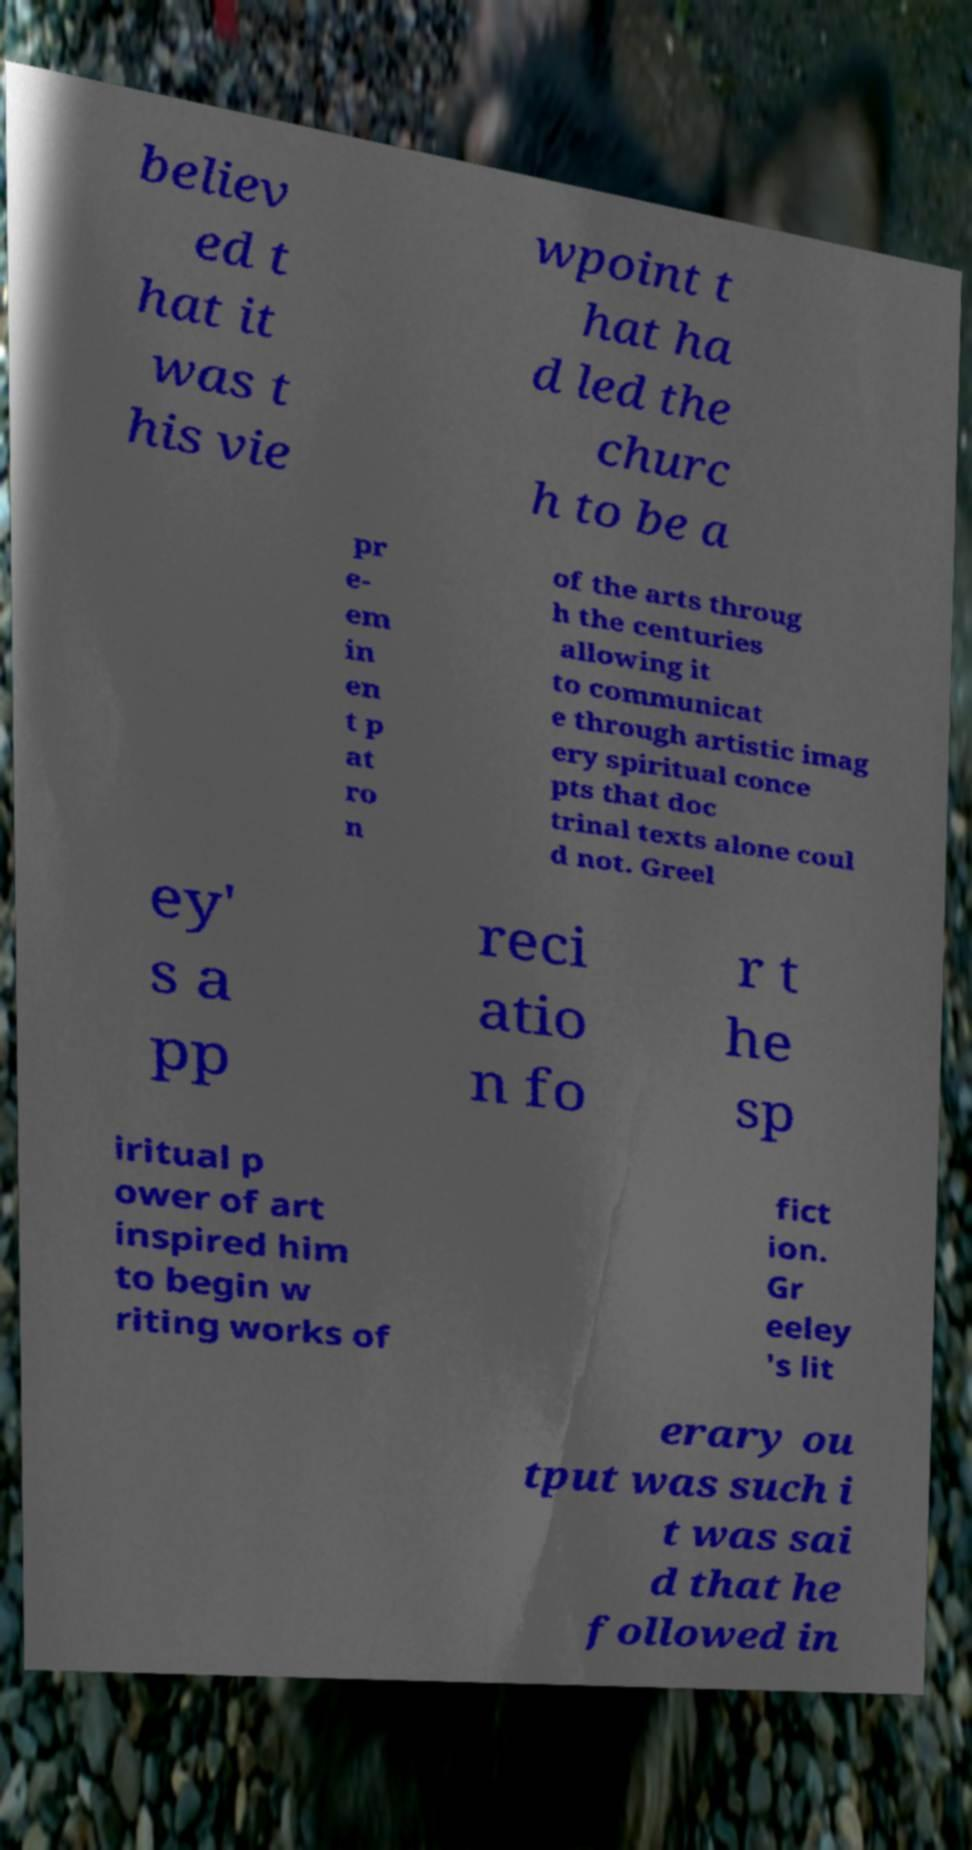Can you read and provide the text displayed in the image?This photo seems to have some interesting text. Can you extract and type it out for me? believ ed t hat it was t his vie wpoint t hat ha d led the churc h to be a pr e- em in en t p at ro n of the arts throug h the centuries allowing it to communicat e through artistic imag ery spiritual conce pts that doc trinal texts alone coul d not. Greel ey' s a pp reci atio n fo r t he sp iritual p ower of art inspired him to begin w riting works of fict ion. Gr eeley 's lit erary ou tput was such i t was sai d that he followed in 